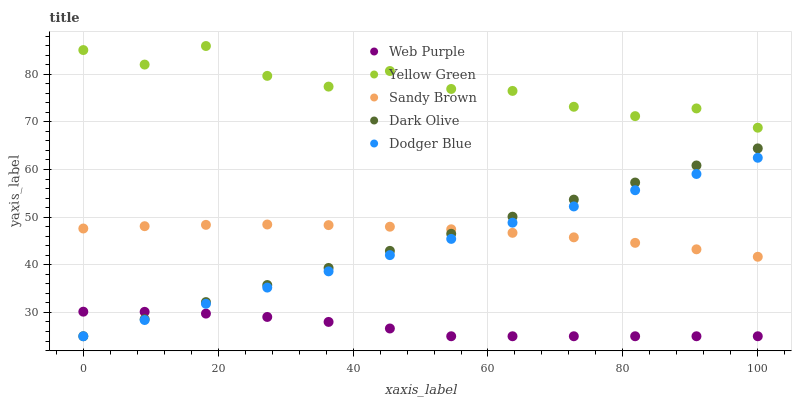Does Web Purple have the minimum area under the curve?
Answer yes or no. Yes. Does Yellow Green have the maximum area under the curve?
Answer yes or no. Yes. Does Dark Olive have the minimum area under the curve?
Answer yes or no. No. Does Dark Olive have the maximum area under the curve?
Answer yes or no. No. Is Dodger Blue the smoothest?
Answer yes or no. Yes. Is Yellow Green the roughest?
Answer yes or no. Yes. Is Web Purple the smoothest?
Answer yes or no. No. Is Web Purple the roughest?
Answer yes or no. No. Does Dodger Blue have the lowest value?
Answer yes or no. Yes. Does Sandy Brown have the lowest value?
Answer yes or no. No. Does Yellow Green have the highest value?
Answer yes or no. Yes. Does Dark Olive have the highest value?
Answer yes or no. No. Is Dodger Blue less than Yellow Green?
Answer yes or no. Yes. Is Yellow Green greater than Web Purple?
Answer yes or no. Yes. Does Dodger Blue intersect Sandy Brown?
Answer yes or no. Yes. Is Dodger Blue less than Sandy Brown?
Answer yes or no. No. Is Dodger Blue greater than Sandy Brown?
Answer yes or no. No. Does Dodger Blue intersect Yellow Green?
Answer yes or no. No. 